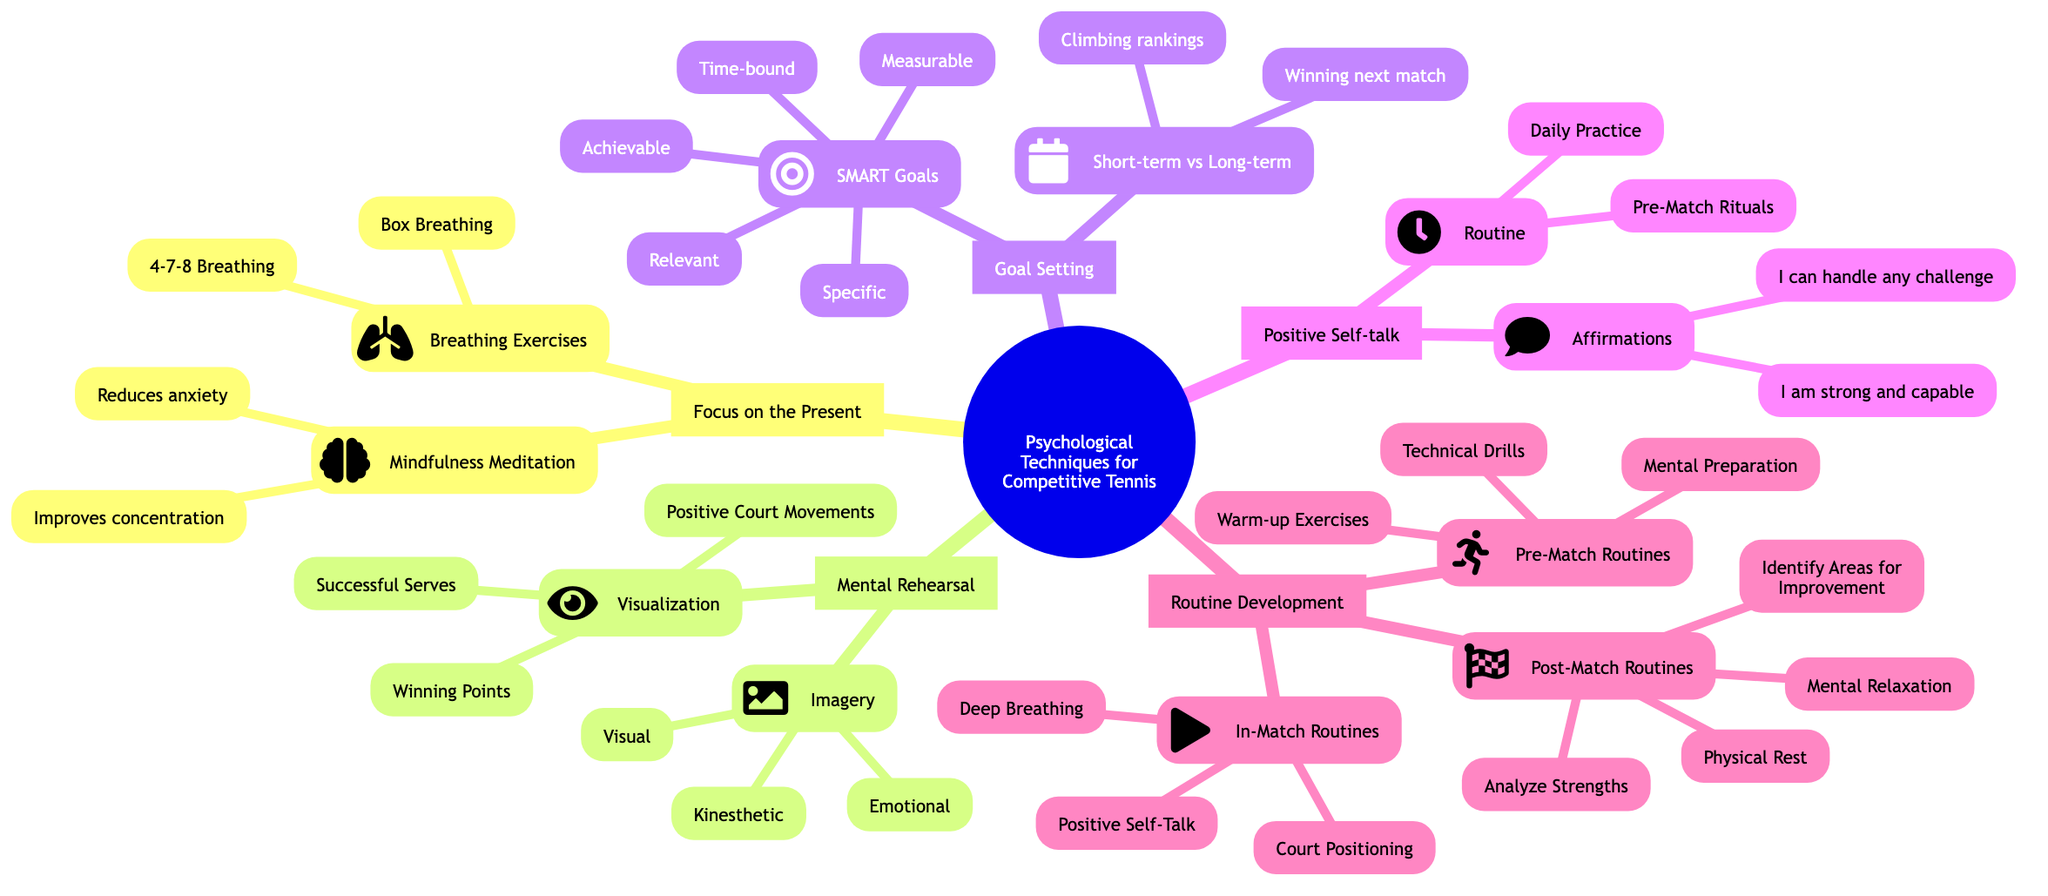What is the main focus of the mind map? The main focus is indicated at the root of the diagram, which is "Psychological Techniques for Competitive Tennis." This encompasses all the techniques discussed in the branches below.
Answer: Psychological Techniques for Competitive Tennis How many main techniques are outlined in the diagram? The diagram presents five main techniques, as represented by five branches stemming from the root node. These are "Focus on the Present," "Mental Rehearsal," "Goal Setting," "Positive Self-talk," and "Routine Development."
Answer: 5 What technique includes the use of "4-7-8 Breathing"? "4-7-8 Breathing" is specifically listed under the "Breathing Exercises" node, which is a sub-category of the "Focus on the Present" technique.
Answer: Breathing Exercises What type of goals does SMART stand for? The diagram explains that SMART goals should be Specific, Measurable, Achievable, Relevant, and Time-bound, which are listed under "SMART Goals."
Answer: Specific, Measurable, Achievable, Relevant, Time-bound What is an element of "Post-Match Routines"? Among the elements mentioned in "Post-Match Routines," the diagram lists "Analyze Strengths" as one of the activities involved in reflecting on performance after a match.
Answer: Analyze Strengths What are the three types involved in "Imagery"? The diagram details three types under "Imagery": Visual, Kinesthetic, and Emotional. This categorization highlights various aspects of imagery that can be used in mental rehearsal.
Answer: Visual, Kinesthetic, Emotional What should be included in daily practice according to "Positive Self-talk"? The diagram explicitly states that affirmations should be included in daily practice, which refers to positive declarations made regularly to enhance confidence and mindset.
Answer: Affirmations What is a suggested frequency for "Visualization"? The diagram recommends a daily practice frequency for Visualization, implying that consistent visualization efforts are crucial for optimal performance preparation.
Answer: Daily practice 